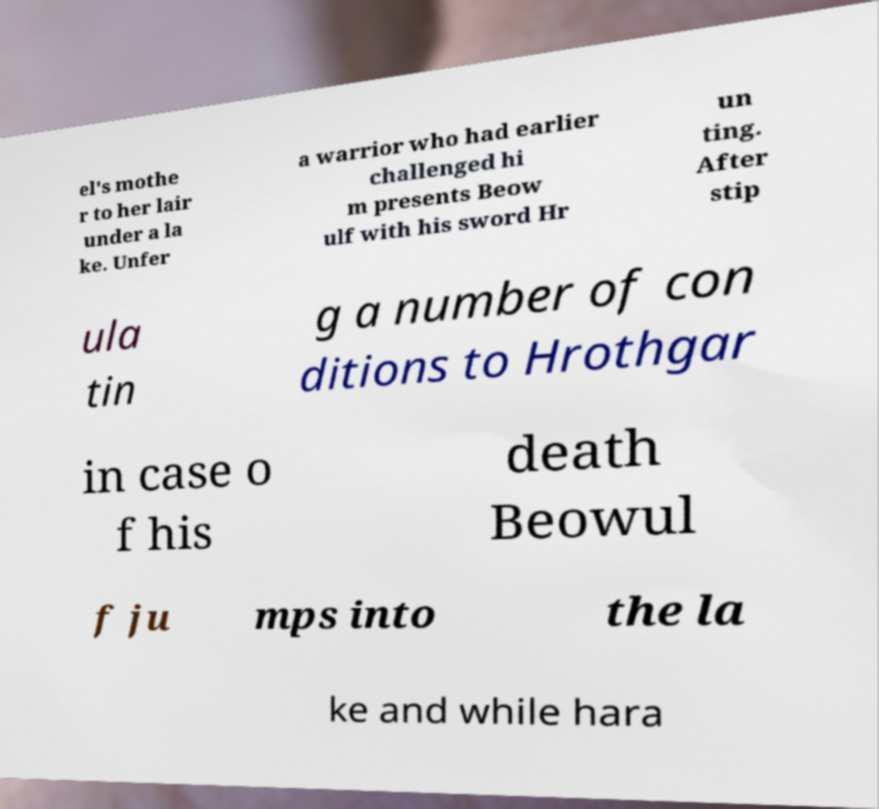Can you read and provide the text displayed in the image?This photo seems to have some interesting text. Can you extract and type it out for me? el's mothe r to her lair under a la ke. Unfer a warrior who had earlier challenged hi m presents Beow ulf with his sword Hr un ting. After stip ula tin g a number of con ditions to Hrothgar in case o f his death Beowul f ju mps into the la ke and while hara 